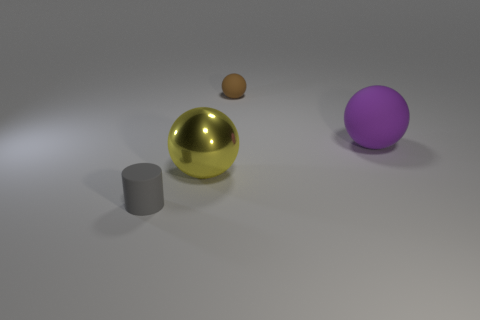Is the number of yellow metallic spheres on the right side of the large purple matte object less than the number of big yellow metal spheres behind the cylinder?
Provide a short and direct response. Yes. How many other objects are there of the same size as the cylinder?
Provide a succinct answer. 1. Is the gray cylinder made of the same material as the small thing behind the cylinder?
Offer a very short reply. Yes. How many objects are small things that are in front of the large metal sphere or tiny matte things that are in front of the big yellow metal sphere?
Keep it short and to the point. 1. What color is the rubber cylinder?
Your answer should be very brief. Gray. Is the number of purple things that are to the right of the purple matte sphere less than the number of purple matte balls?
Your response must be concise. Yes. Are there any other things that have the same shape as the big purple matte object?
Give a very brief answer. Yes. Is there a tiny brown rubber sphere?
Your answer should be very brief. Yes. Is the number of purple objects less than the number of large brown matte balls?
Provide a short and direct response. No. How many tiny brown things have the same material as the brown ball?
Give a very brief answer. 0. 